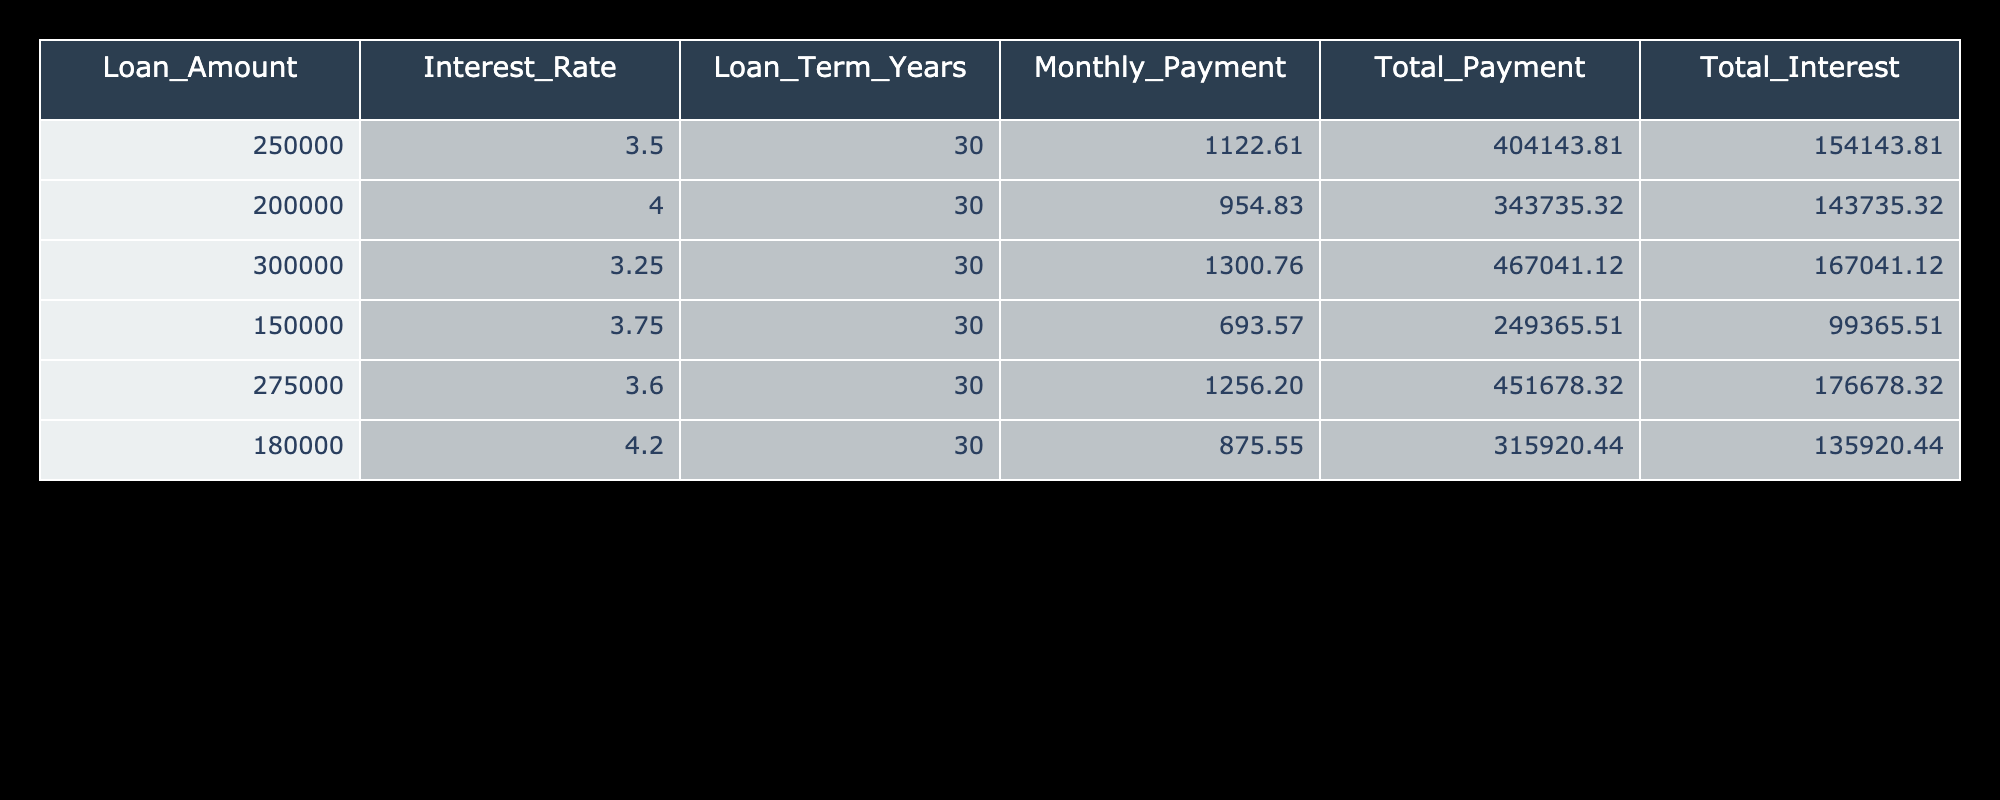What's the monthly payment for a loan amount of $250,000? The table shows the row for a loan amount of $250,000, which clearly lists the monthly payment value. That value is 1122.61.
Answer: 1122.61 What is the total payment for a $200,000 mortgage? Looking at the row for the $200,000 mortgage, the total payment is displayed, which is 343735.32.
Answer: 343735.32 How much total interest will be paid on the $300,000 loan? The total interest for the $300,000 loan is found in its corresponding row, which is 167041.12.
Answer: 167041.12 Is a loan of $150,000 with an interest rate of 3.75% considered a higher interest rate compared to a $200,000 loan at 4%? Comparing the interest rates in the table, 3.75% (for $150,000) is less than 4% (for $200,000). Thus, the statement is false.
Answer: No What is the difference in total payments between the $275,000 loan and the $180,000 loan? The total payment for the $275,000 loan is 451678.32, and for the $180,000 loan, it is 315920.44. The difference is calculated as 451678.32 - 315920.44 = 135757.88.
Answer: 135757.88 What is the average monthly payment for all the loans listed? The monthly payments from all loans are (1122.61, 954.83, 1300.76, 693.57, 1256.20, 875.55). Summing these gives 5103.72, and dividing by 6 gives an average of 850.62.
Answer: 850.62 Which loan has the highest total interest paid? By scanning the total interest column for all loans, the $275,000 loan at an interest rate of 3.6% has the highest total interest, which is 176678.32.
Answer: $275,000 loan What is the median total payment among the loans? The total payments in order are 249365.51, 343735.32, 404143.81, 451678.32, 467041.12. As there are six payments, the median is the average of the 3rd and 4th values: (404143.81 + 451678.32) / 2 = 427911.06.
Answer: 427911.06 Is the monthly payment for the $180,000 loan lower than $900? The monthly payment for the $180,000 loan is 875.55, which is indeed lower than $900, thus the statement is true.
Answer: Yes 